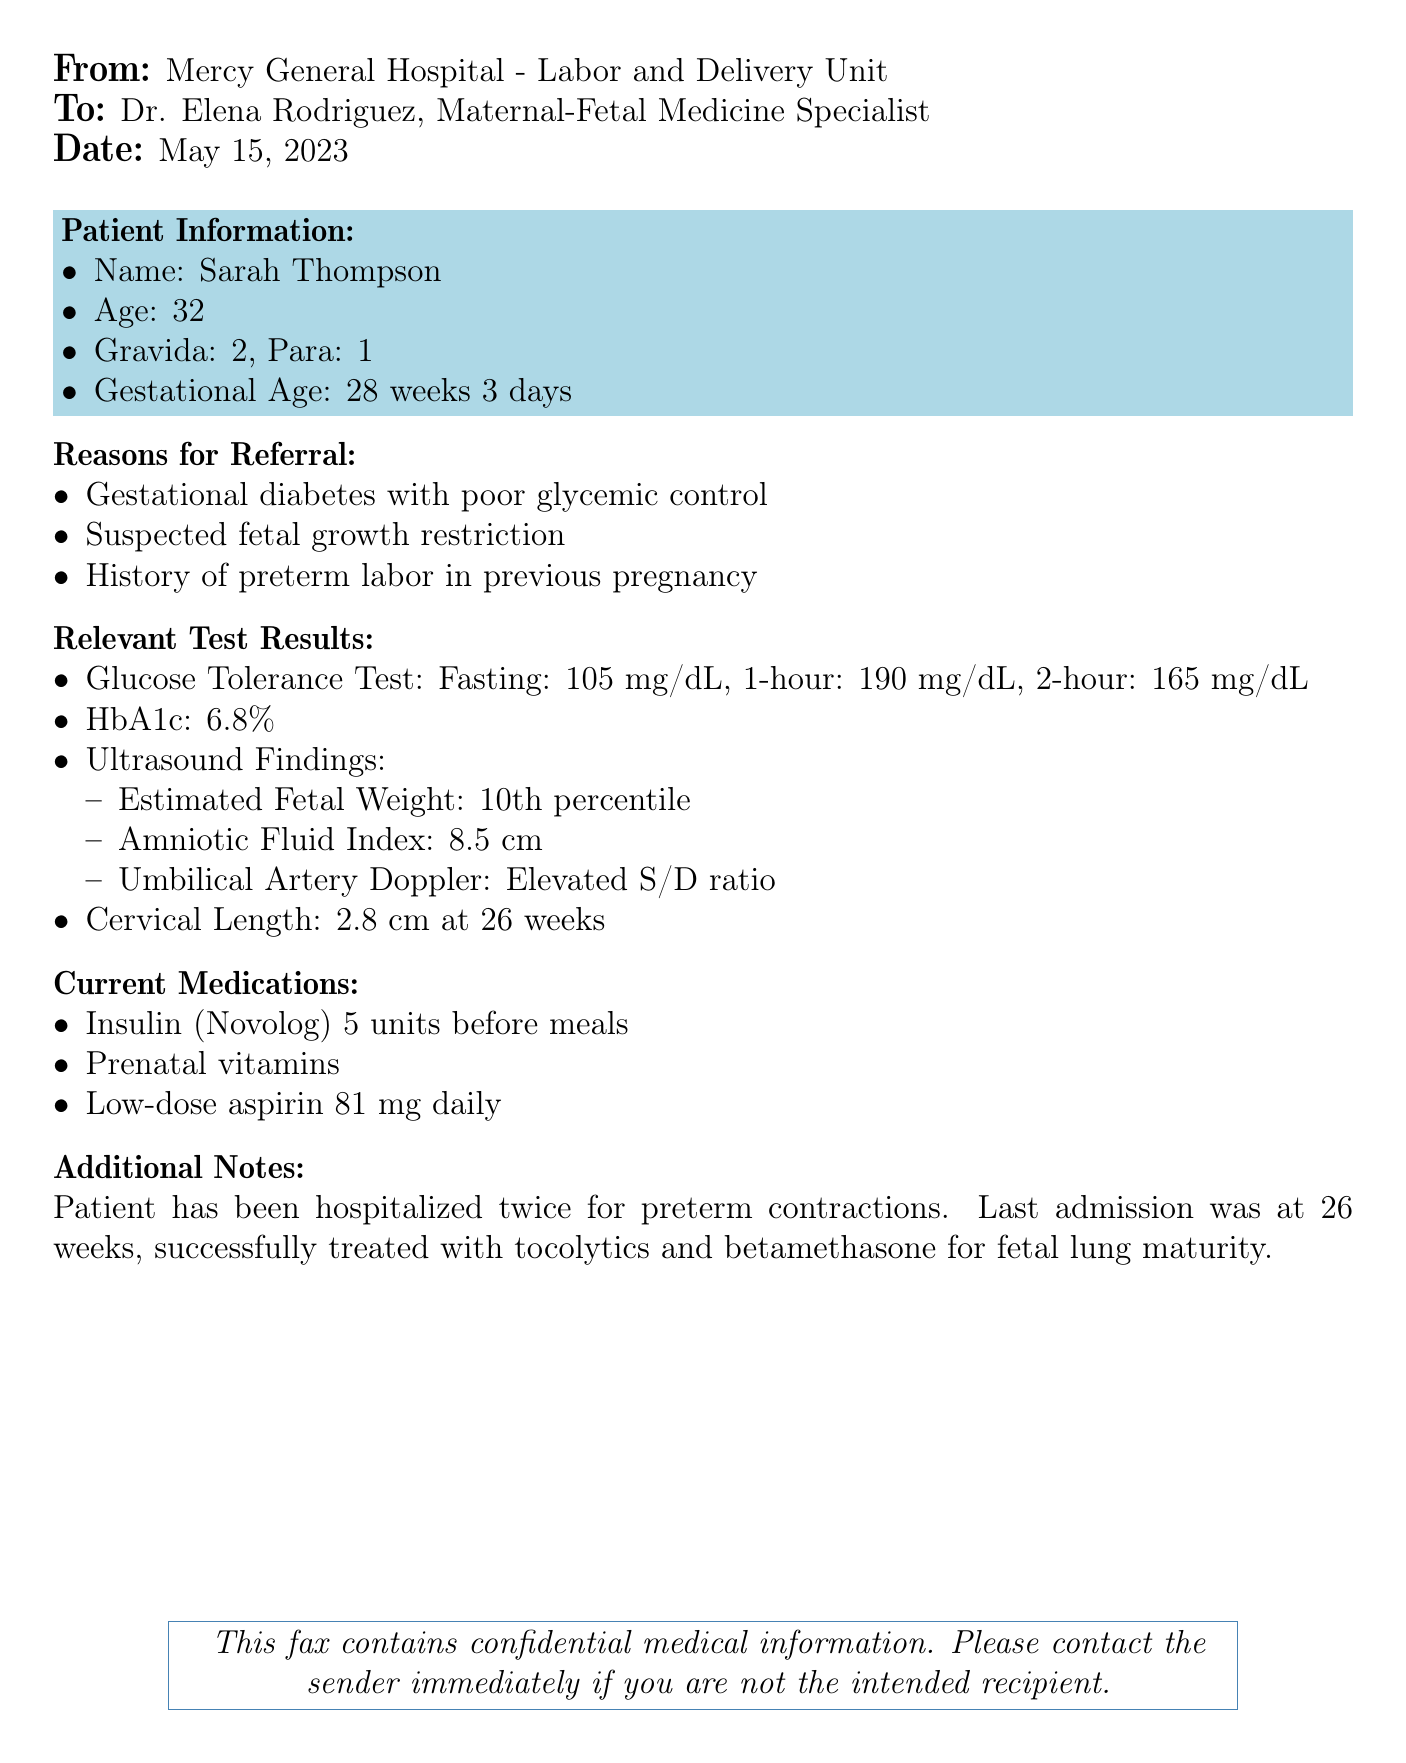What is the patient's name? The patient's name is explicitly mentioned in the document.
Answer: Sarah Thompson What is the gestational age of the patient? The gestational age is specified under patient information in the document.
Answer: 28 weeks 3 days What is the HbA1c level for the patient? The HbA1c level is provided in the relevant test results section of the document.
Answer: 6.8% What medication is the patient taking daily? The current medications section lists this information.
Answer: Low-dose aspirin 81 mg daily What percent is the estimated fetal weight? The estimated fetal weight is mentioned as a specific percentile in the ultrasound findings.
Answer: 10th percentile What was the fasting glucose level from the Glucose Tolerance Test? The fasting glucose level is recorded in the relevant test results section of the document.
Answer: 105 mg/dL How many times has the patient been hospitalized for preterm contractions? This information is included in the additional notes section of the document.
Answer: Twice What additional treatment did the patient receive for fetal lung maturity? The document lists treatments used during the patient's last admission.
Answer: Betamethasone What was the cervical length at 26 weeks? The cervical length is specifically mentioned in the relevant test results section.
Answer: 2.8 cm 